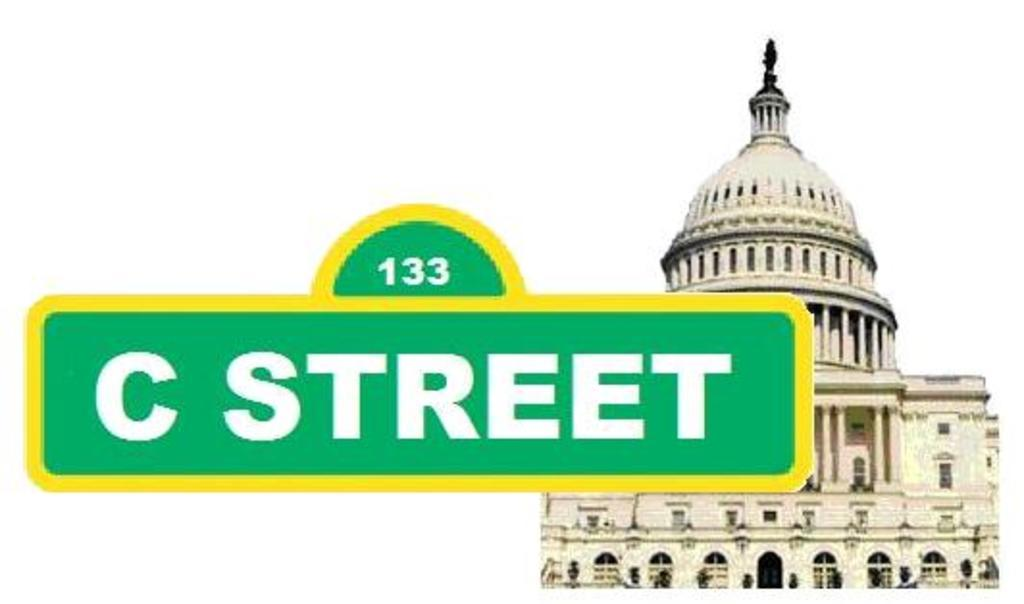What type of visual is the image? The image appears to be a poster. What can be seen on the right side of the poster? There is a building visible on the right side of the image. What is present on the left side of the image? There is text and a number on the left side of the image, resembling a name board. How many apples are hanging from the building in the image? There are no apples present in the image; the building is the main focus on the right side. 